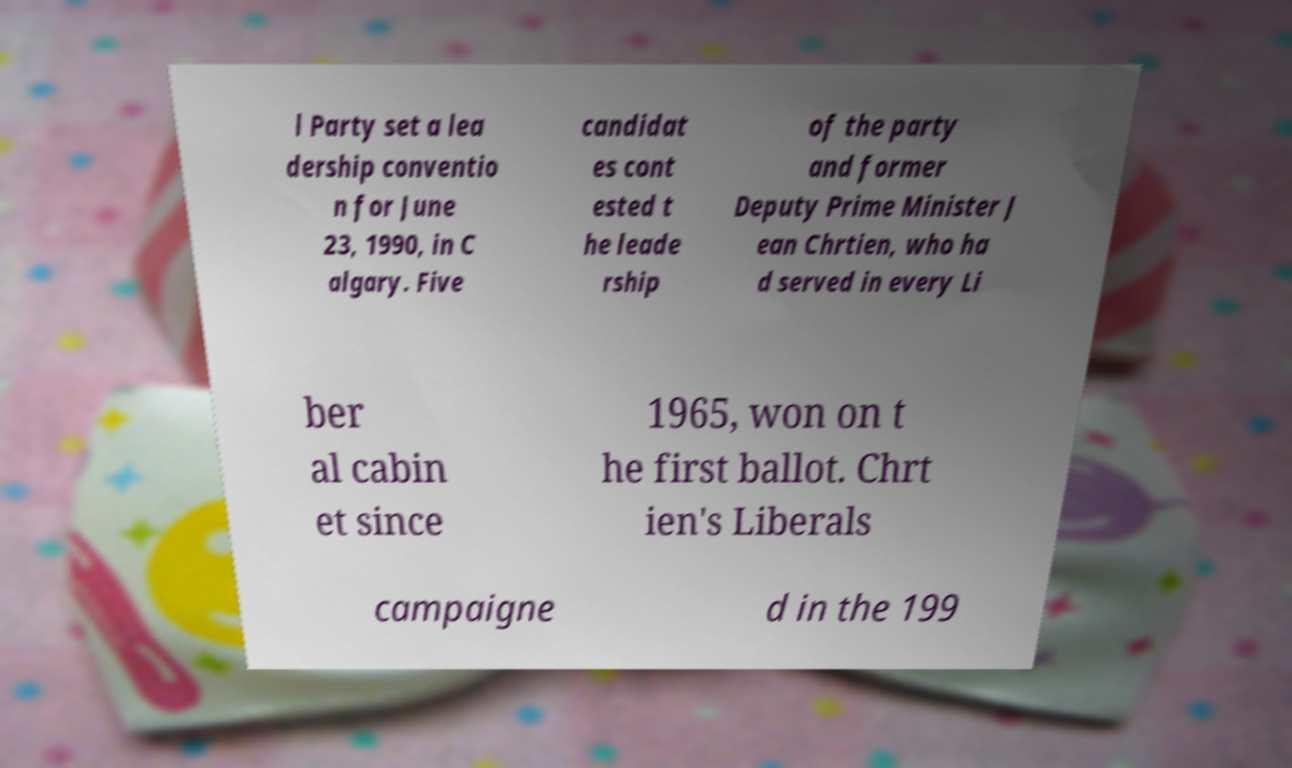Could you extract and type out the text from this image? l Party set a lea dership conventio n for June 23, 1990, in C algary. Five candidat es cont ested t he leade rship of the party and former Deputy Prime Minister J ean Chrtien, who ha d served in every Li ber al cabin et since 1965, won on t he first ballot. Chrt ien's Liberals campaigne d in the 199 